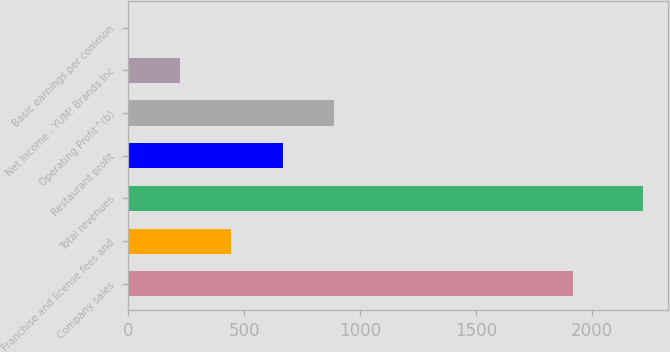<chart> <loc_0><loc_0><loc_500><loc_500><bar_chart><fcel>Company sales<fcel>Franchise and license fees and<fcel>Total revenues<fcel>Restaurant profit<fcel>Operating Profit^(b)<fcel>Net Income - YUM! Brands Inc<fcel>Basic earnings per common<nl><fcel>1918<fcel>443.77<fcel>2217<fcel>665.42<fcel>887.07<fcel>222.12<fcel>0.47<nl></chart> 